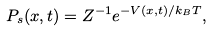Convert formula to latex. <formula><loc_0><loc_0><loc_500><loc_500>P _ { s } ( x , t ) = Z ^ { - 1 } e ^ { - V ( x , t ) / k _ { B } T } ,</formula> 